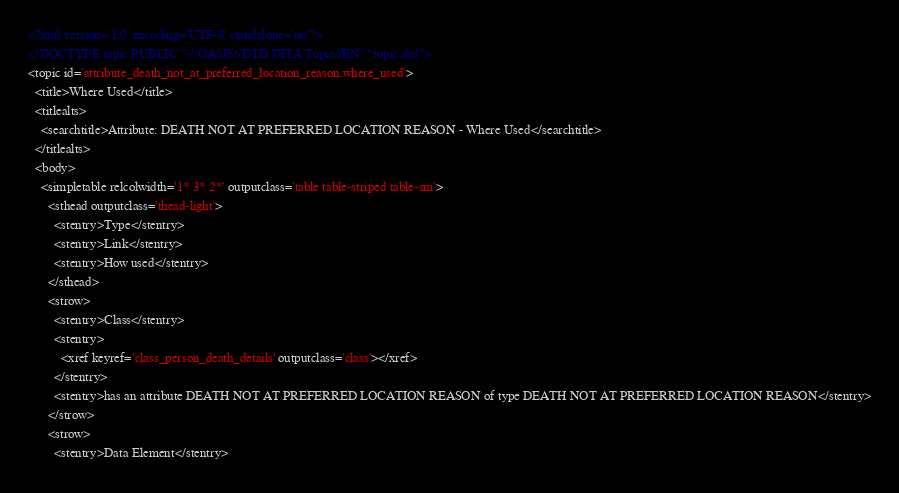<code> <loc_0><loc_0><loc_500><loc_500><_XML_><?xml version='1.0' encoding='UTF-8' standalone='no'?>
<!DOCTYPE topic PUBLIC "-//OASIS//DTD DITA Topic//EN" "topic.dtd">
<topic id='attribute_death_not_at_preferred_location_reason.where_used'>
  <title>Where Used</title>
  <titlealts>
    <searchtitle>Attribute: DEATH NOT AT PREFERRED LOCATION REASON - Where Used</searchtitle>
  </titlealts>
  <body>
    <simpletable relcolwidth='1* 3* 2*' outputclass='table table-striped table-sm'>
      <sthead outputclass='thead-light'>
        <stentry>Type</stentry>
        <stentry>Link</stentry>
        <stentry>How used</stentry>
      </sthead>
      <strow>
        <stentry>Class</stentry>
        <stentry>
          <xref keyref='class_person_death_details' outputclass='class'></xref>
        </stentry>
        <stentry>has an attribute DEATH NOT AT PREFERRED LOCATION REASON of type DEATH NOT AT PREFERRED LOCATION REASON</stentry>
      </strow>
      <strow>
        <stentry>Data Element</stentry></code> 